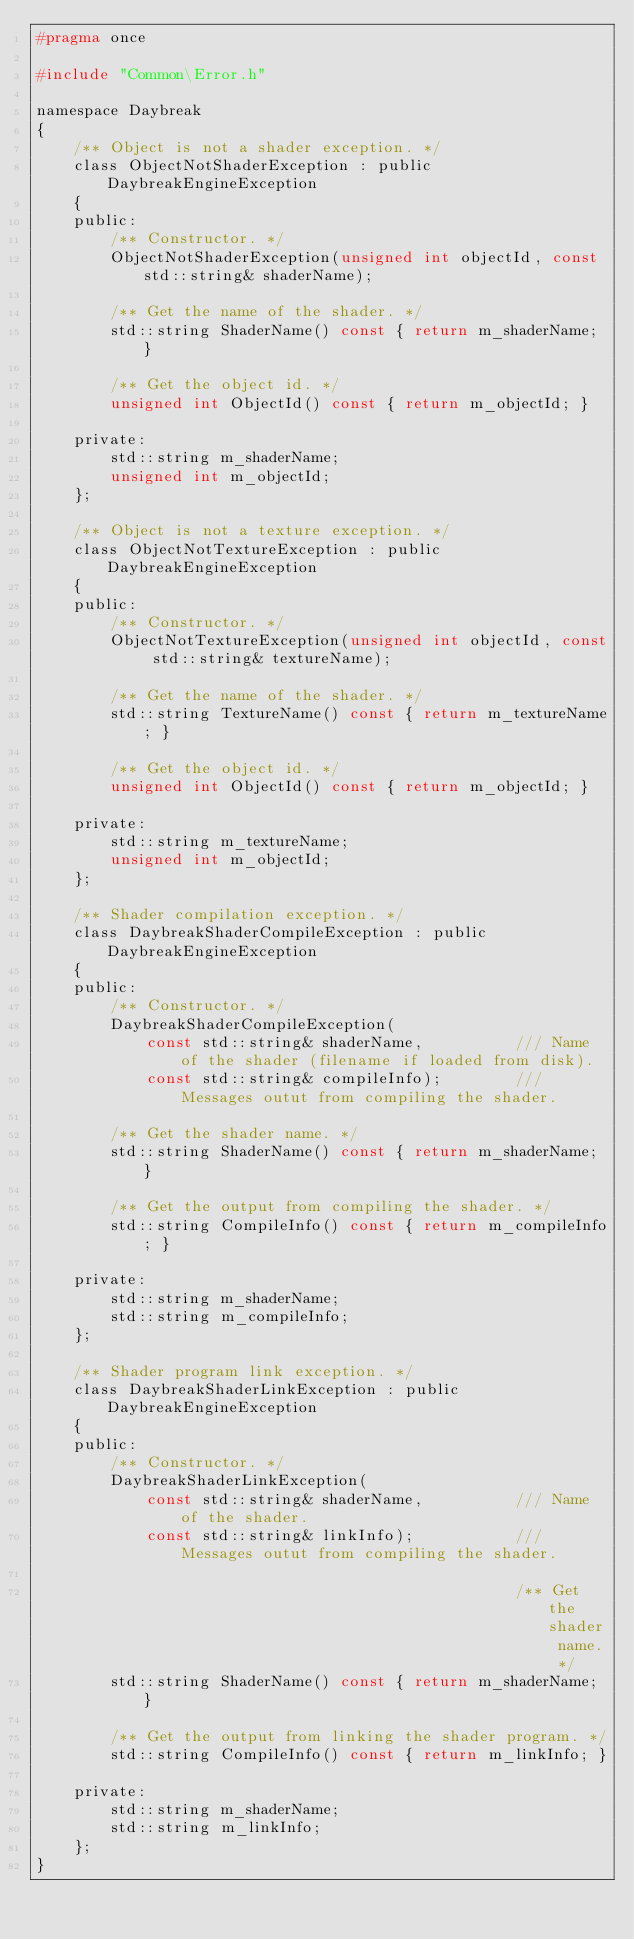<code> <loc_0><loc_0><loc_500><loc_500><_C_>#pragma once

#include "Common\Error.h"

namespace Daybreak
{
    /** Object is not a shader exception. */
    class ObjectNotShaderException : public DaybreakEngineException
    {
    public:
        /** Constructor. */
        ObjectNotShaderException(unsigned int objectId, const std::string& shaderName);

        /** Get the name of the shader. */
        std::string ShaderName() const { return m_shaderName; }

        /** Get the object id. */
        unsigned int ObjectId() const { return m_objectId; }

    private:
        std::string m_shaderName;
        unsigned int m_objectId;
    };

    /** Object is not a texture exception. */
    class ObjectNotTextureException : public DaybreakEngineException
    {
    public:
        /** Constructor. */
        ObjectNotTextureException(unsigned int objectId, const std::string& textureName);

        /** Get the name of the shader. */
        std::string TextureName() const { return m_textureName; }

        /** Get the object id. */
        unsigned int ObjectId() const { return m_objectId; }

    private:
        std::string m_textureName;
        unsigned int m_objectId;
    };

    /** Shader compilation exception. */
    class DaybreakShaderCompileException : public DaybreakEngineException
    {
    public:
        /** Constructor. */
        DaybreakShaderCompileException(
            const std::string& shaderName,          /// Name of the shader (filename if loaded from disk).
            const std::string& compileInfo);        /// Messages outut from compiling the shader.

        /** Get the shader name. */
        std::string ShaderName() const { return m_shaderName; }

        /** Get the output from compiling the shader. */
        std::string CompileInfo() const { return m_compileInfo; }

    private:
        std::string m_shaderName;
        std::string m_compileInfo;
    };

    /** Shader program link exception. */
    class DaybreakShaderLinkException : public DaybreakEngineException
    {
    public:
        /** Constructor. */
        DaybreakShaderLinkException(
            const std::string& shaderName,          /// Name of the shader.
            const std::string& linkInfo);           /// Messages outut from compiling the shader.

                                                    /** Get the shader name. */
        std::string ShaderName() const { return m_shaderName; }

        /** Get the output from linking the shader program. */
        std::string CompileInfo() const { return m_linkInfo; }

    private:
        std::string m_shaderName;
        std::string m_linkInfo;
    };
}
</code> 